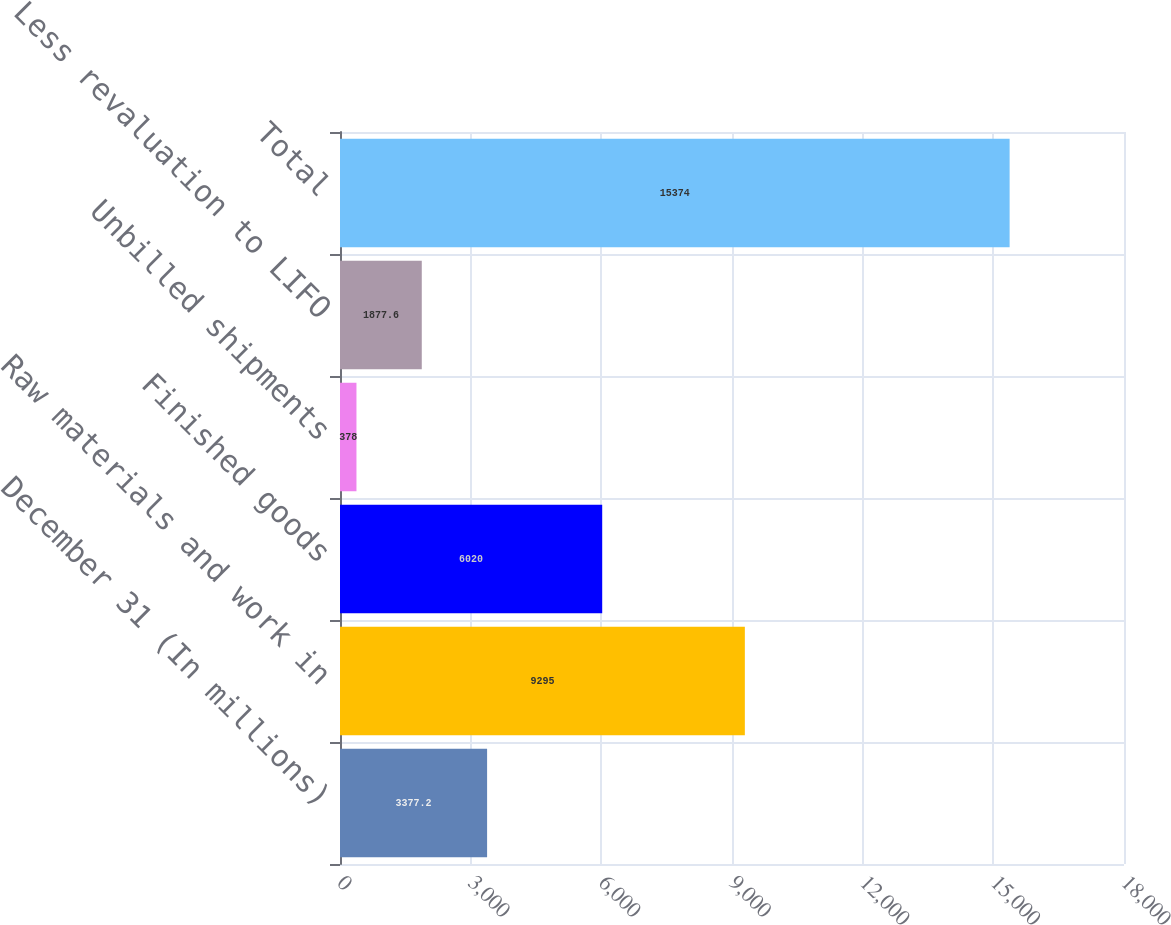<chart> <loc_0><loc_0><loc_500><loc_500><bar_chart><fcel>December 31 (In millions)<fcel>Raw materials and work in<fcel>Finished goods<fcel>Unbilled shipments<fcel>Less revaluation to LIFO<fcel>Total<nl><fcel>3377.2<fcel>9295<fcel>6020<fcel>378<fcel>1877.6<fcel>15374<nl></chart> 